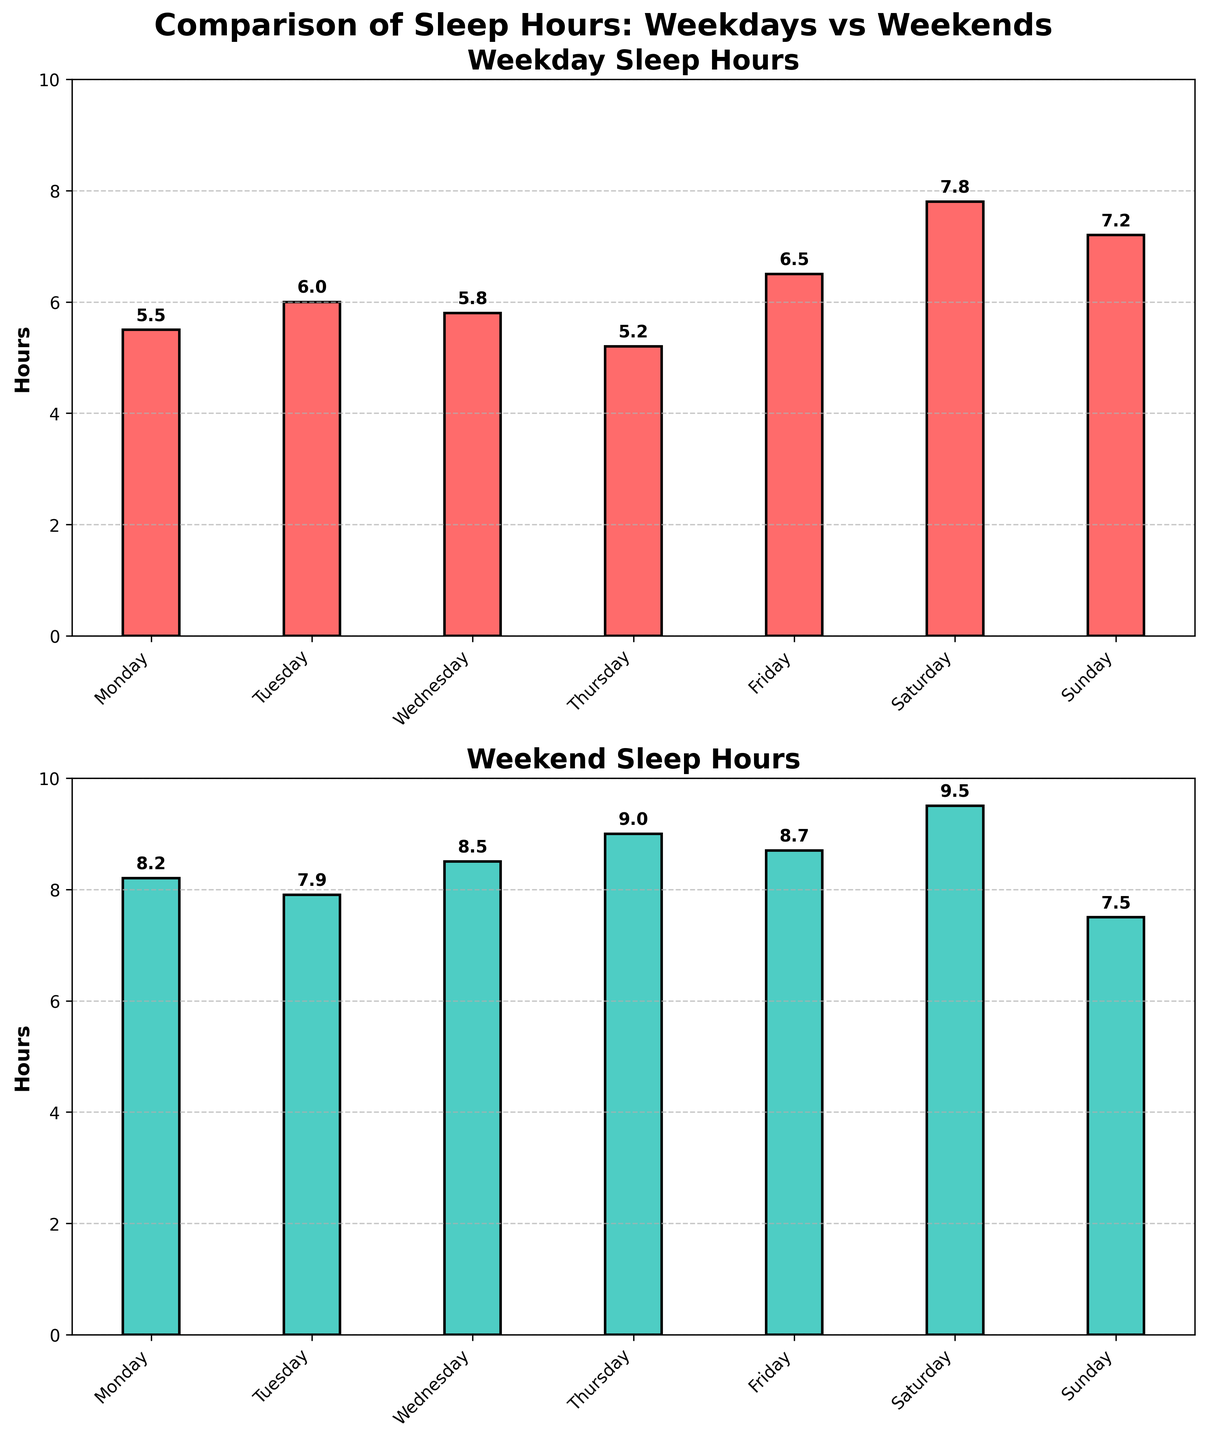What is the title of the first subplot? The title of the first subplot is displayed on top of the first bar chart, it describes what the chart represents.
Answer: Weekday Sleep Hours How many days are represented in the figure? Count the number of distinct labels on the x-axis of both subplots, as both plots represent the same days.
Answer: 7 On which day do students get the least amount of sleep on weekdays? Identify the day with the smallest bar in the "Weekday Sleep Hours" subplot by comparing the height of each bar.
Answer: Thursday What is the range of hours for weekend sleep? The range is the difference between the maximum and minimum values in the "Weekend Sleep Hours" subplot. Max value is 9.5 (Saturday) and min value is 7.5 (Sunday). Range = 9.5 - 7.5.
Answer: 2.0 Which day has the highest difference in sleep hours between weekdays and weekends? Calculate the absolute difference in sleep hours for each day and identify the day with the largest difference. Thursday: 9.0 - 5.2 = 3.8, the largest difference.
Answer: Thursday What is the average sleep hours for weekdays? Add the weekday sleep hours for each day, then divide by the number of days: (5.5 + 6.0 + 5.8 + 5.2 + 6.5 + 7.8 + 7.2) / 7.
Answer: 6.0 Do students sleep more on weekends compared to weekdays? Compare the general heights of bars in the "Weekday Sleep Hours" and "Weekend Sleep Hours" subplots. Most weekend bars are higher than weekday bars.
Answer: Yes By how many hours does the sleep increase on average from weekdays to weekends? Calculate the average for weekdays (6.0) and weekends (8.19), then find the difference: 8.19 - 6.0.
Answer: 2.19 What color is used to represent weekend sleep hours in the subplot? Check the color used in the "Weekend Sleep Hours" subplot, as represented visually in the figure.
Answer: Turquoise On which day is the sleep difference between weekdays and weekends the smallest? Calculate the absolute difference for each day and find the smallest one. Sunday:
Answer: Sunday 